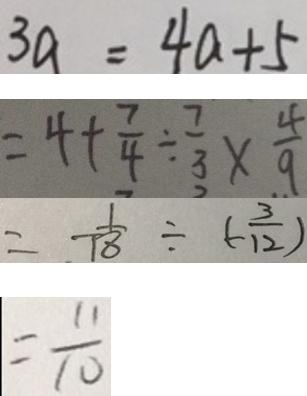Convert formula to latex. <formula><loc_0><loc_0><loc_500><loc_500>3 a = 4 a + 5 
 = 4 + \frac { 7 } { 4 } \div \frac { 7 } { 3 } \times \frac { 4 } { 9 } 
 = - \frac { 1 } { 1 8 } \div ( - \frac { 3 } { 1 2 } ) 
 = \frac { 1 1 } { 1 0 }</formula> 